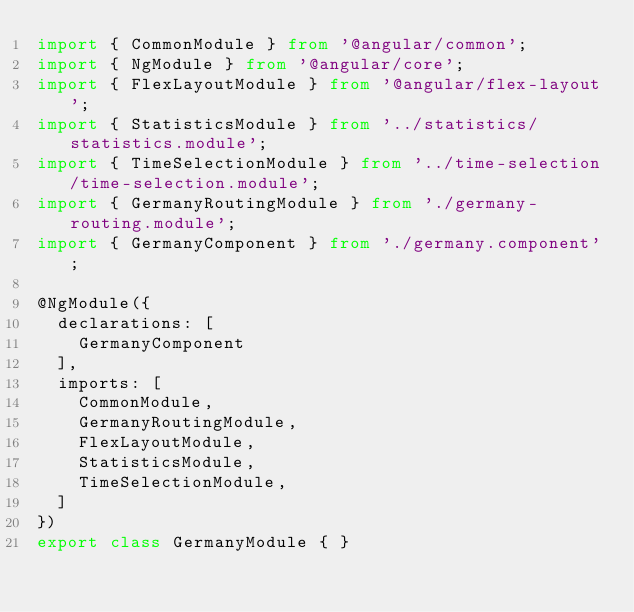<code> <loc_0><loc_0><loc_500><loc_500><_TypeScript_>import { CommonModule } from '@angular/common';
import { NgModule } from '@angular/core';
import { FlexLayoutModule } from '@angular/flex-layout';
import { StatisticsModule } from '../statistics/statistics.module';
import { TimeSelectionModule } from '../time-selection/time-selection.module';
import { GermanyRoutingModule } from './germany-routing.module';
import { GermanyComponent } from './germany.component';

@NgModule({
  declarations: [
    GermanyComponent
  ],
  imports: [
    CommonModule,
    GermanyRoutingModule,
    FlexLayoutModule,
    StatisticsModule,
    TimeSelectionModule,
  ]
})
export class GermanyModule { }
</code> 